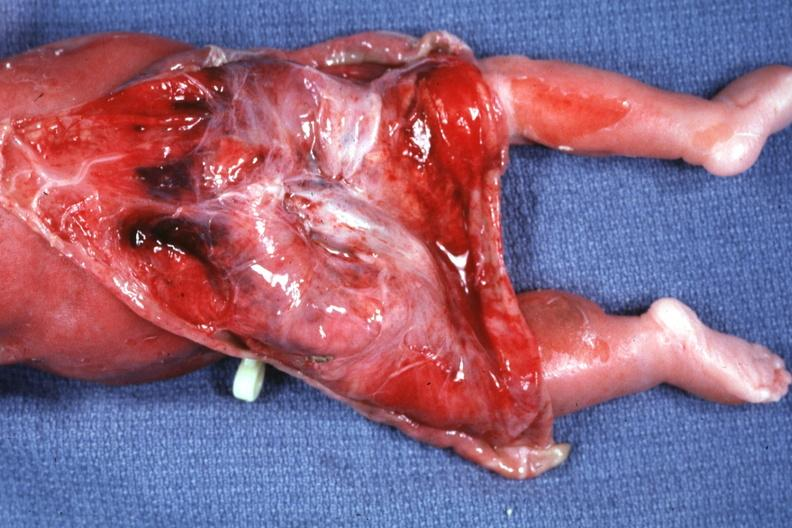what is present?
Answer the question using a single word or phrase. Sacrococcygeal teratoma 